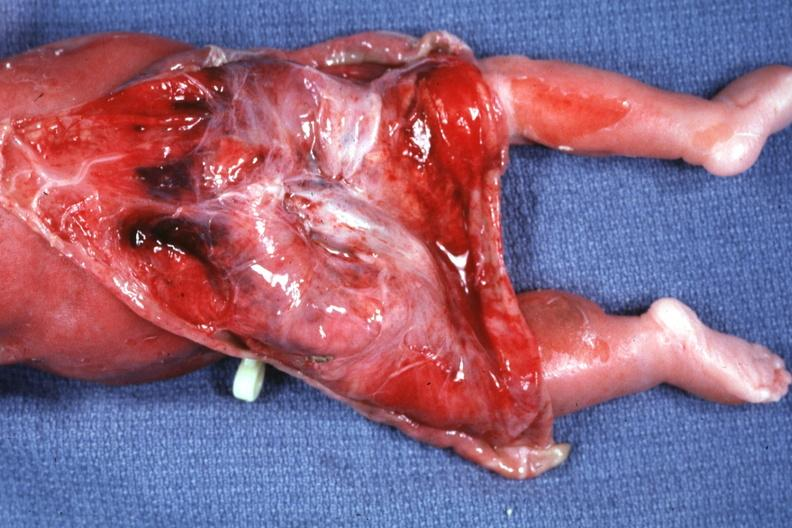what is present?
Answer the question using a single word or phrase. Sacrococcygeal teratoma 